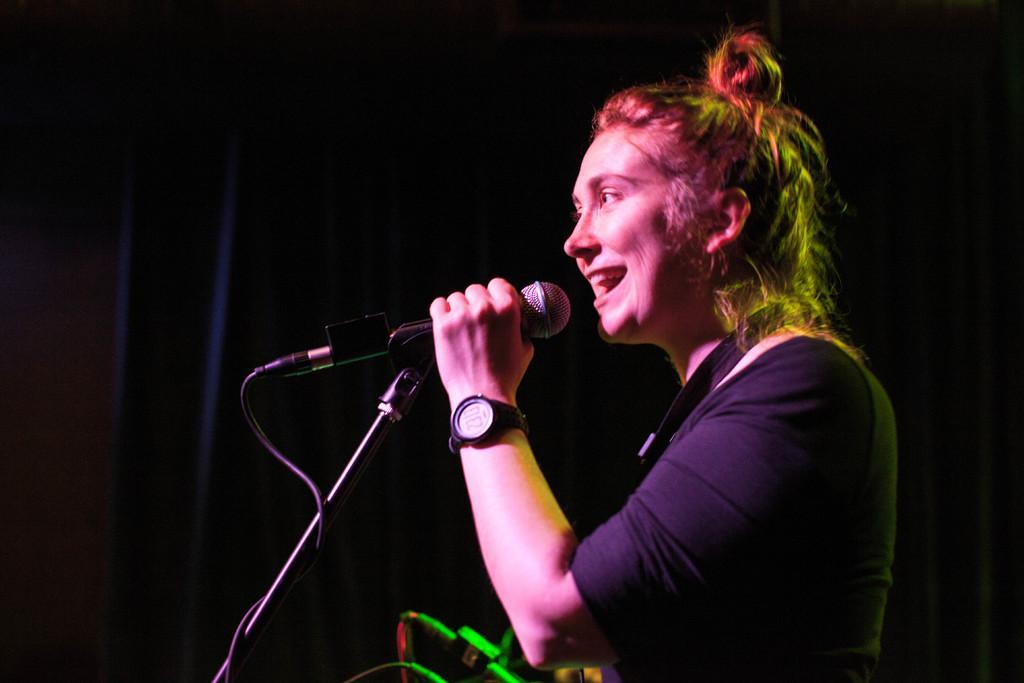Could you give a brief overview of what you see in this image? In this image we can see a woman holding the mike and also wearing the watch. In the background we can see the black color curtain and we can also see some wires at the bottom. 